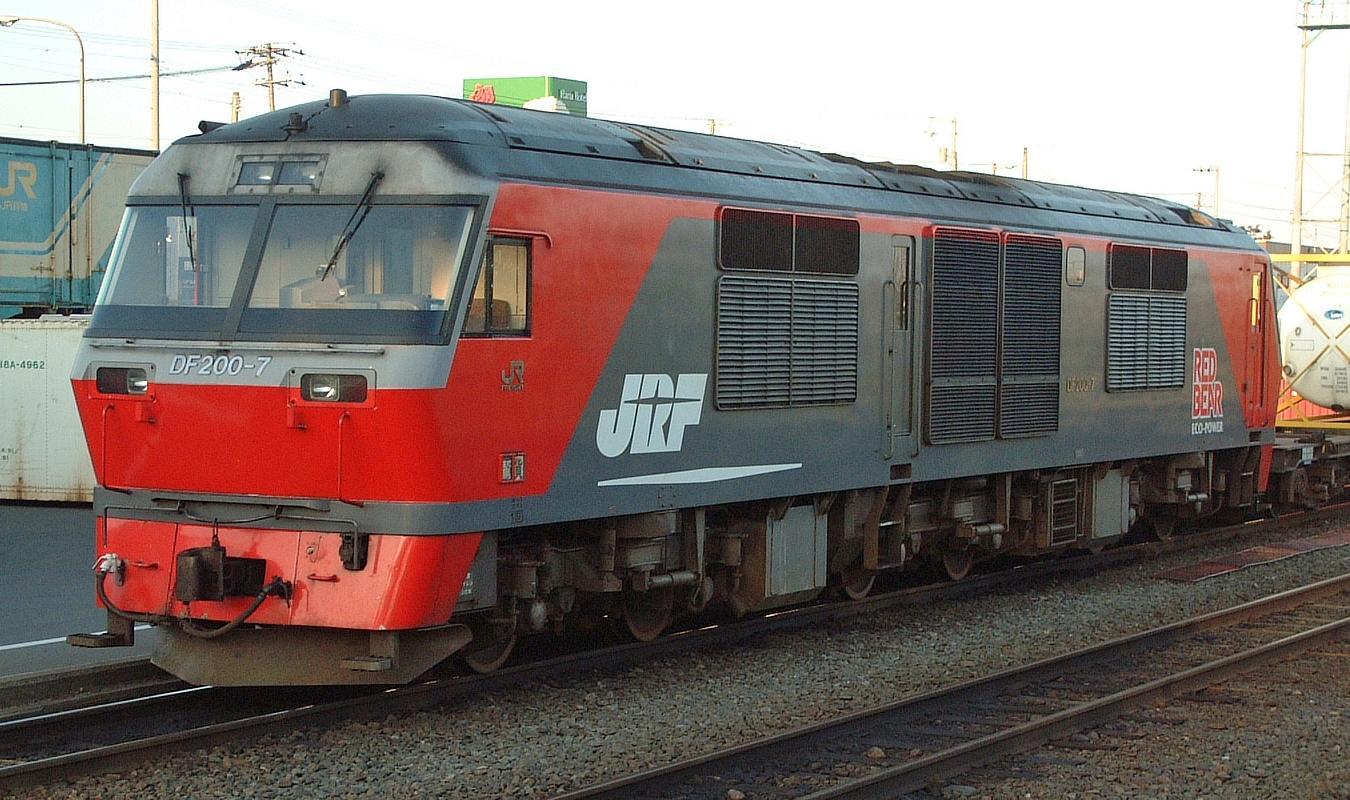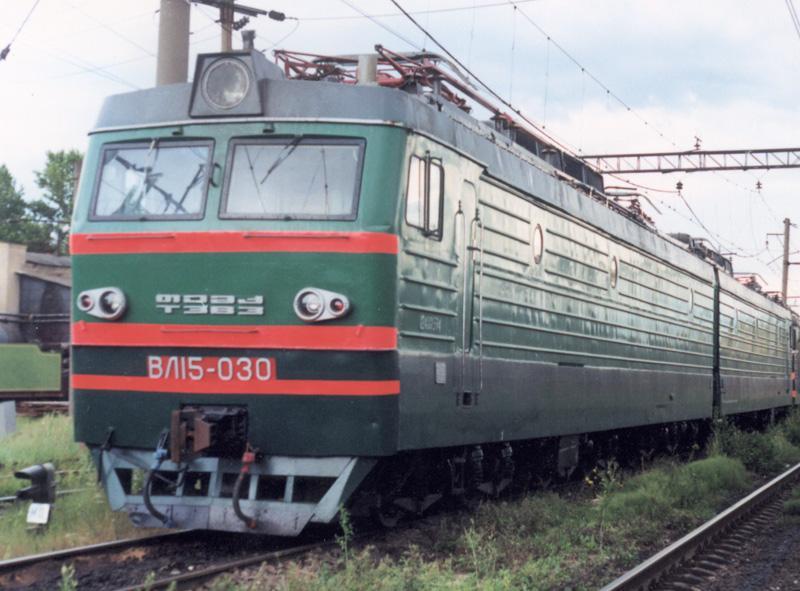The first image is the image on the left, the second image is the image on the right. For the images shown, is this caption "Both trains are facing left" true? Answer yes or no. Yes. 